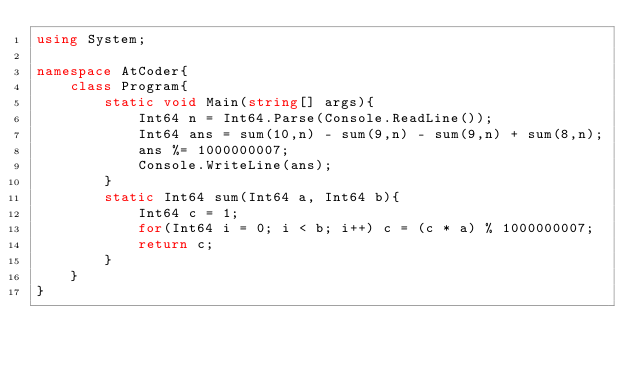Convert code to text. <code><loc_0><loc_0><loc_500><loc_500><_C#_>using System;

namespace AtCoder{
    class Program{
        static void Main(string[] args){
            Int64 n = Int64.Parse(Console.ReadLine());
            Int64 ans = sum(10,n) - sum(9,n) - sum(9,n) + sum(8,n);
            ans %= 1000000007;
            Console.WriteLine(ans);
        }
        static Int64 sum(Int64 a, Int64 b){
            Int64 c = 1;
            for(Int64 i = 0; i < b; i++) c = (c * a) % 1000000007;
            return c;
        }
    }
}
</code> 